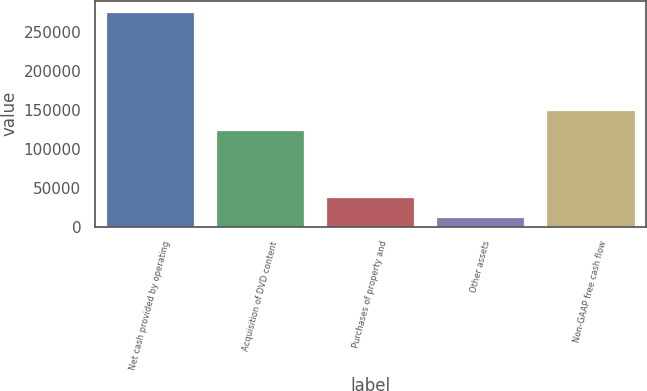Convert chart. <chart><loc_0><loc_0><loc_500><loc_500><bar_chart><fcel>Net cash provided by operating<fcel>Acquisition of DVD content<fcel>Purchases of property and<fcel>Other assets<fcel>Non-GAAP free cash flow<nl><fcel>276401<fcel>123901<fcel>38749.7<fcel>12344<fcel>150307<nl></chart> 